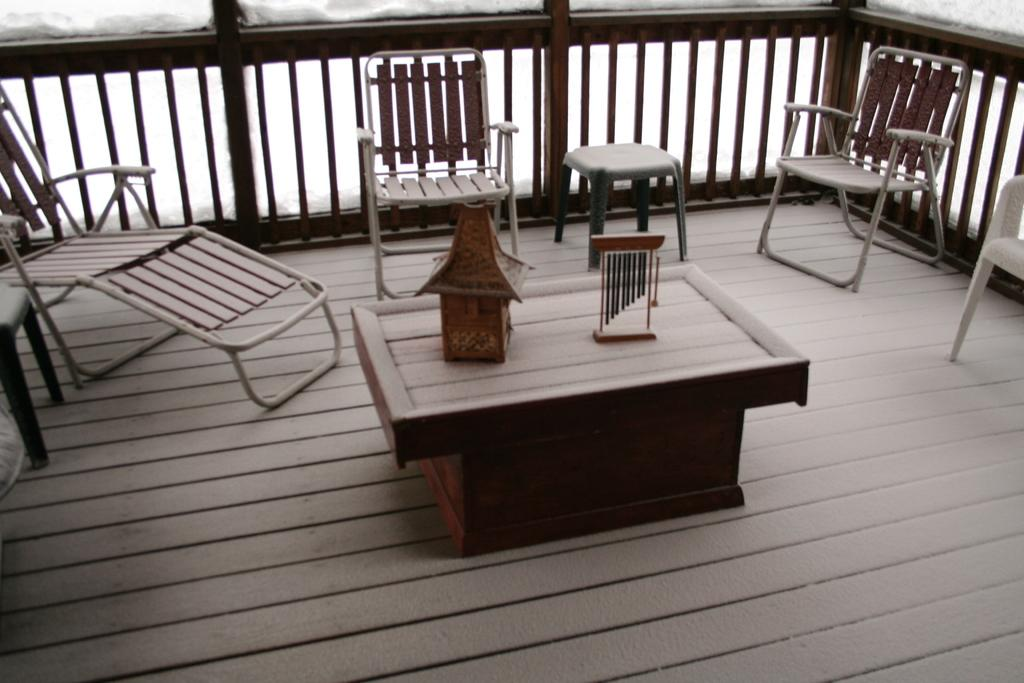What type of flooring is visible in the image? There is a wooden floor in the image. What is placed on the wooden floor? There is a table on the wooden floor. What can be seen on the table? There are decorative items on the table. What type of seating is present in the image? There are chairs and stools in the image. What can be seen in the background of the image? There is a railing in the background of the image. What type of thrill can be experienced by the goose in the image? There is no goose present in the image, and therefore no thrill can be experienced. 